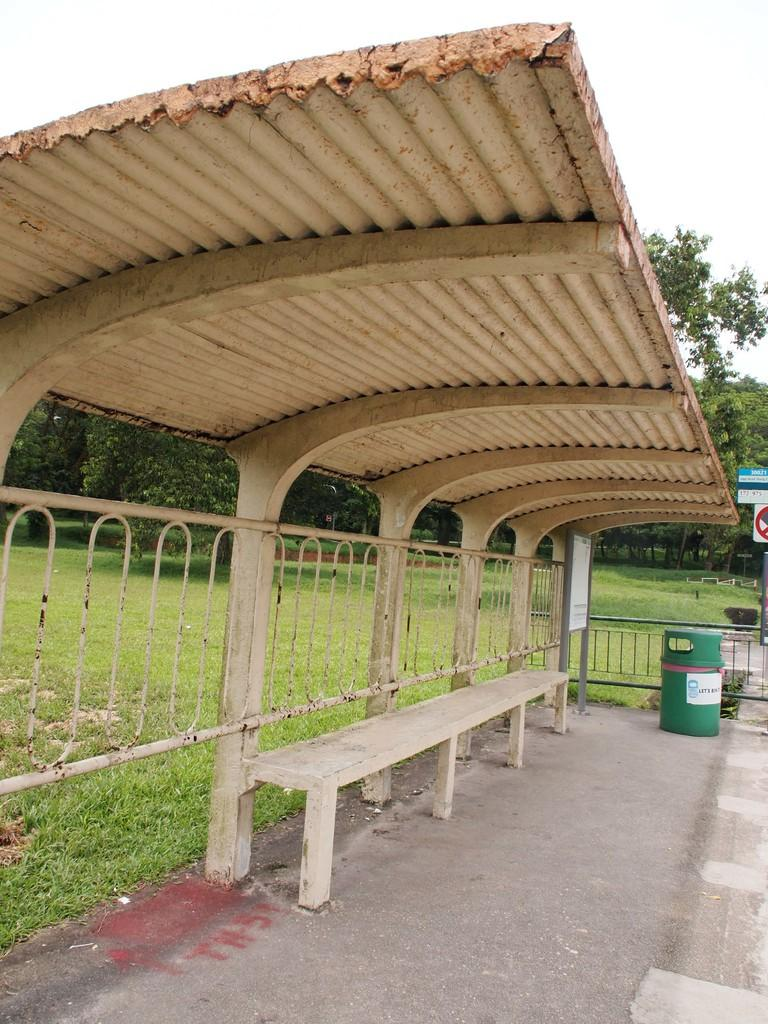What type of structure is in the image? There is a shelter in the image. What is located under the shelter? There is a bench under the shelter. What is placed beside the bench? There is a dustbin beside the bench. What can be seen in the background of the image? There is a garden in the background of the image, with trees and the sky visible. What type of ink can be seen spilling from the popcorn in the image? There is no ink or popcorn present in the image; it features a shelter, bench, dustbin, and a garden with trees. 